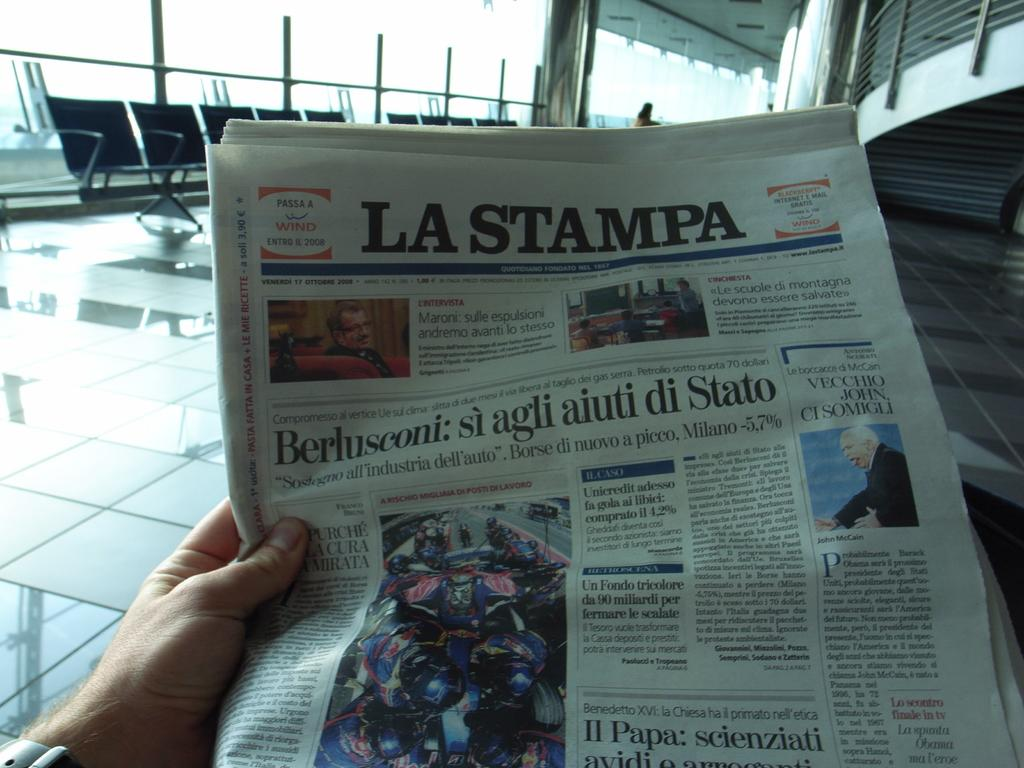What is the person in the image holding? The person's hand is holding a newspaper in the image. Can you describe the person in the image? There is a person in the image, but no specific details about their appearance are provided. What type of furniture is visible in the image? There are chairs in the image. What architectural feature can be seen in the background of the image? There are railings in the background of the image. How many cats are sitting on the person's lap in the image? There are no cats present in the image. What is the person's net worth based on the image? The image does not provide any information about the person's wealth. What type of sign is visible in the image? There is no sign present in the image. 